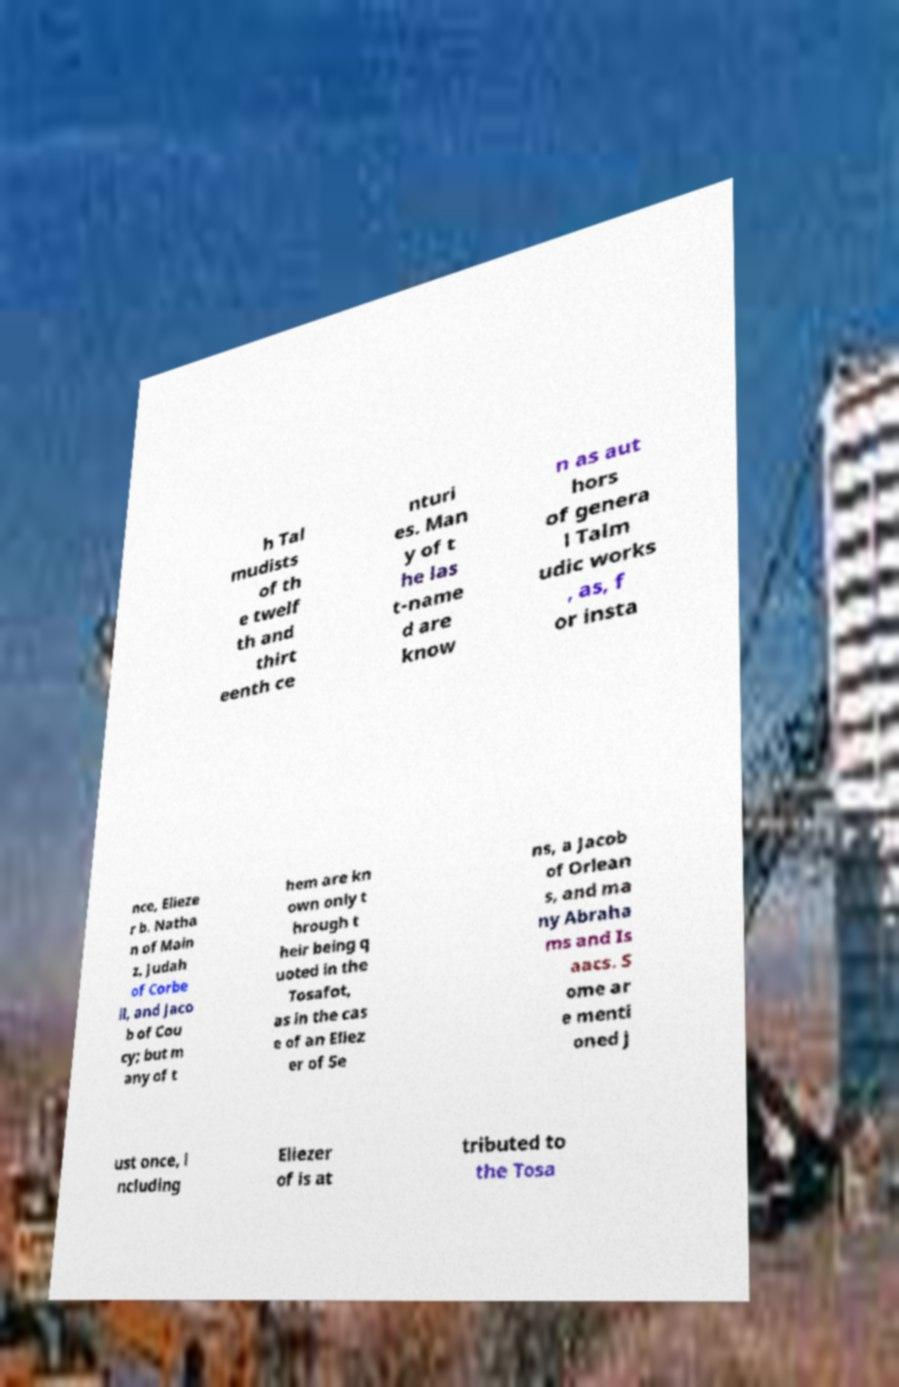I need the written content from this picture converted into text. Can you do that? h Tal mudists of th e twelf th and thirt eenth ce nturi es. Man y of t he las t-name d are know n as aut hors of genera l Talm udic works , as, f or insta nce, Elieze r b. Natha n of Main z, Judah of Corbe il, and Jaco b of Cou cy; but m any of t hem are kn own only t hrough t heir being q uoted in the Tosafot, as in the cas e of an Eliez er of Se ns, a Jacob of Orlean s, and ma ny Abraha ms and Is aacs. S ome ar e menti oned j ust once, i ncluding Eliezer of is at tributed to the Tosa 